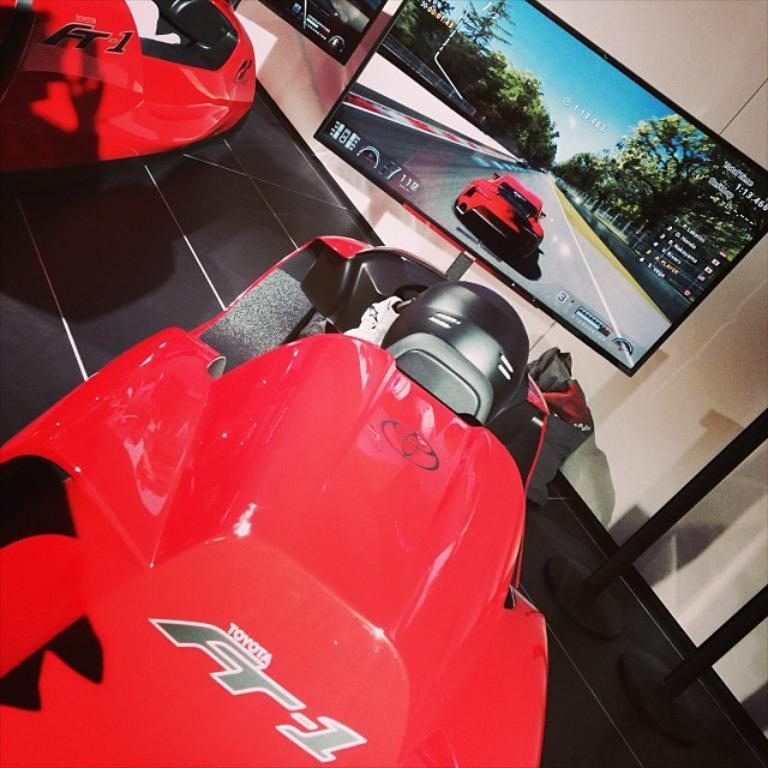What is the main subject in the foreground of the picture? There is a car in the foreground of the picture. What is located in the center of the picture? There is a television in the center of the picture. What can be seen on the left side of the picture? There is another car and a television on the left side of the picture. What is present on the right side of the picture? There are stands on the right side of the picture. Can you tell me how many goldfish are swimming in the stands on the right side of the picture? There are no goldfish present in the image; the stands are empty. What type of chalk is being used to draw on the television in the center of the picture? There is no chalk or drawing activity depicted on the television in the image. 